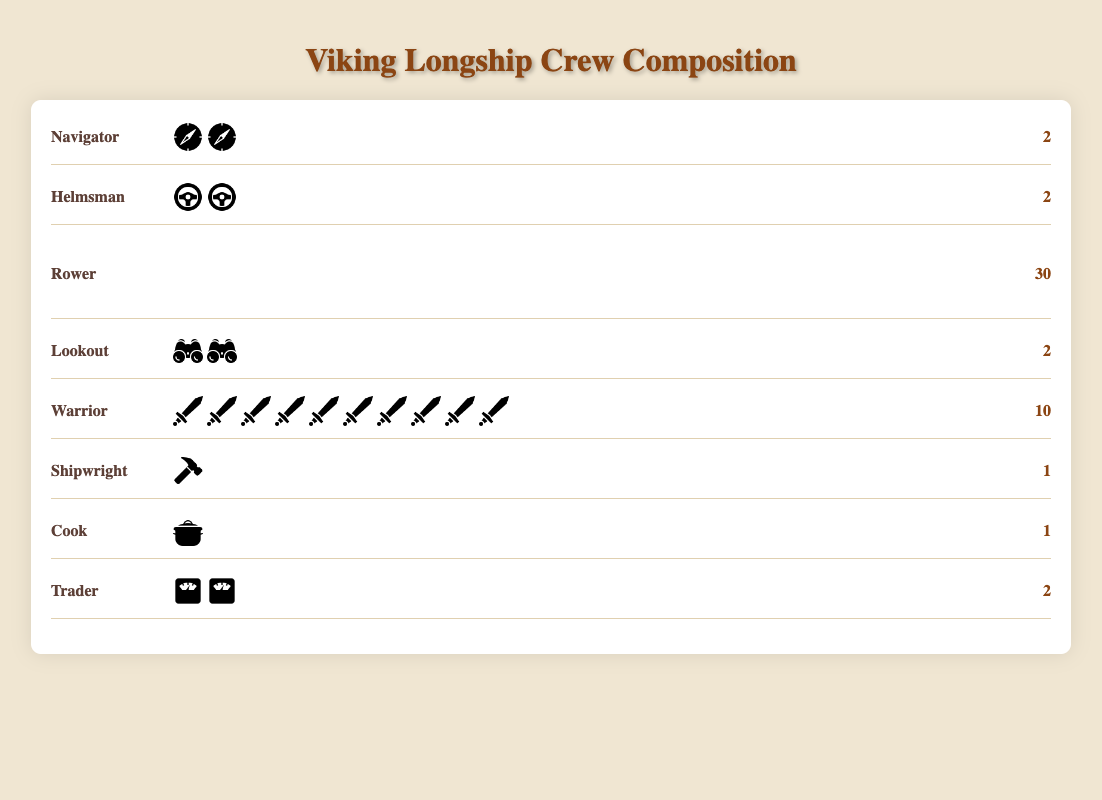How many more rowers are there than warriors in the Viking longship crew? Count the number of rowers (30) and the number of warriors (10) in the figure. Subtract the count of warriors from the count of rowers: 30 - 10 = 20.
Answer: 20 Which role has the fewest members in the Viking longship crew? Look for the role with the lowest count. Both the Shipwright and the Cook have 1 member each.
Answer: Shipwright and Cook What is the total number of crew members on the Viking longship? Add up the counts for all roles: 2 (Navigator) + 2 (Helmsman) + 30 (Rower) + 2 (Lookout) + 10 (Warrior) + 1 (Shipwright) + 1 (Cook) + 2 (Trader) = 50.
Answer: 50 Which roles each have exactly 2 members on the Viking longship? Identify roles with a count of 2 from the figure. These roles are Navigator, Helmsman, Lookout, and Trader.
Answer: Navigator, Helmsman, Lookout, Trader What percentage of the crew is composed of rowers? Find the count of rowers (30) and the total crew count (50). Calculate the percentage: (30 / 50) * 100 = 60%.
Answer: 60% Compare the number of warriors to the combined number of navigators and helmsmen. Which is greater? Find the counts: Warriors (10), Navigators (2), Helmsmen (2). Combine Navigators and Helmsmen: 2 + 2 = 4. Compare: 10 (Warriors) is greater than 4.
Answer: Warriors How many roles have more than 5 members? Identify roles with counts greater than 5. Only the Rowers have a count greater than 5 with 30 members.
Answer: 1 role If the crew added 3 more traders and 2 more cooks, how many cooks would there be? Current number of cooks is 1. Adding 2 more cooks results in 1 + 2 = 3.
Answer: 3 